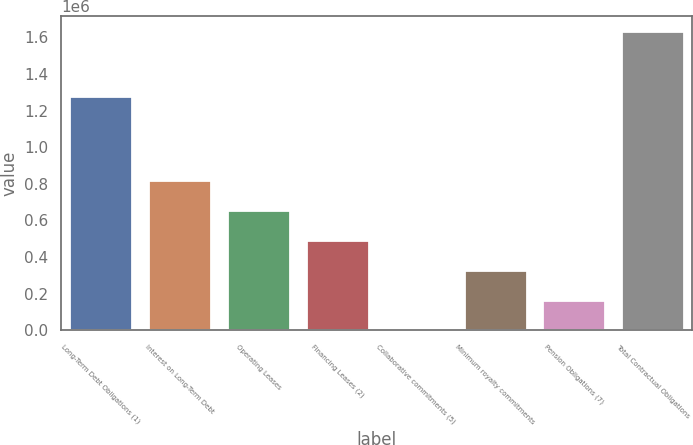Convert chart to OTSL. <chart><loc_0><loc_0><loc_500><loc_500><bar_chart><fcel>Long-Term Debt Obligations (1)<fcel>Interest on Long-Term Debt<fcel>Operating Leases<fcel>Financing Leases (2)<fcel>Collaborative commitments (5)<fcel>Minimum royalty commitments<fcel>Pension Obligations (7)<fcel>Total Contractual Obligations<nl><fcel>1.28e+06<fcel>818058<fcel>654578<fcel>491098<fcel>659<fcel>327618<fcel>164139<fcel>1.63546e+06<nl></chart> 